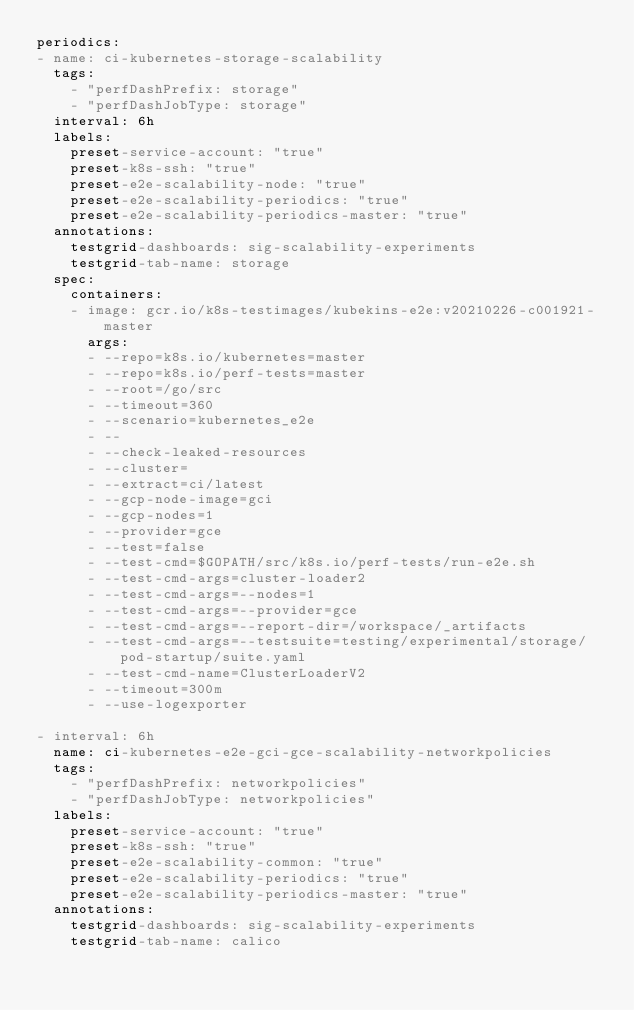<code> <loc_0><loc_0><loc_500><loc_500><_YAML_>periodics:
- name: ci-kubernetes-storage-scalability
  tags:
    - "perfDashPrefix: storage"
    - "perfDashJobType: storage"
  interval: 6h
  labels:
    preset-service-account: "true"
    preset-k8s-ssh: "true"
    preset-e2e-scalability-node: "true"
    preset-e2e-scalability-periodics: "true"
    preset-e2e-scalability-periodics-master: "true"
  annotations:
    testgrid-dashboards: sig-scalability-experiments
    testgrid-tab-name: storage
  spec:
    containers:
    - image: gcr.io/k8s-testimages/kubekins-e2e:v20210226-c001921-master
      args:
      - --repo=k8s.io/kubernetes=master
      - --repo=k8s.io/perf-tests=master
      - --root=/go/src
      - --timeout=360
      - --scenario=kubernetes_e2e
      - --
      - --check-leaked-resources
      - --cluster=
      - --extract=ci/latest
      - --gcp-node-image=gci
      - --gcp-nodes=1
      - --provider=gce
      - --test=false
      - --test-cmd=$GOPATH/src/k8s.io/perf-tests/run-e2e.sh
      - --test-cmd-args=cluster-loader2
      - --test-cmd-args=--nodes=1
      - --test-cmd-args=--provider=gce
      - --test-cmd-args=--report-dir=/workspace/_artifacts
      - --test-cmd-args=--testsuite=testing/experimental/storage/pod-startup/suite.yaml
      - --test-cmd-name=ClusterLoaderV2
      - --timeout=300m
      - --use-logexporter

- interval: 6h
  name: ci-kubernetes-e2e-gci-gce-scalability-networkpolicies
  tags:
    - "perfDashPrefix: networkpolicies"
    - "perfDashJobType: networkpolicies"
  labels:
    preset-service-account: "true"
    preset-k8s-ssh: "true"
    preset-e2e-scalability-common: "true"
    preset-e2e-scalability-periodics: "true"
    preset-e2e-scalability-periodics-master: "true"
  annotations:
    testgrid-dashboards: sig-scalability-experiments
    testgrid-tab-name: calico</code> 